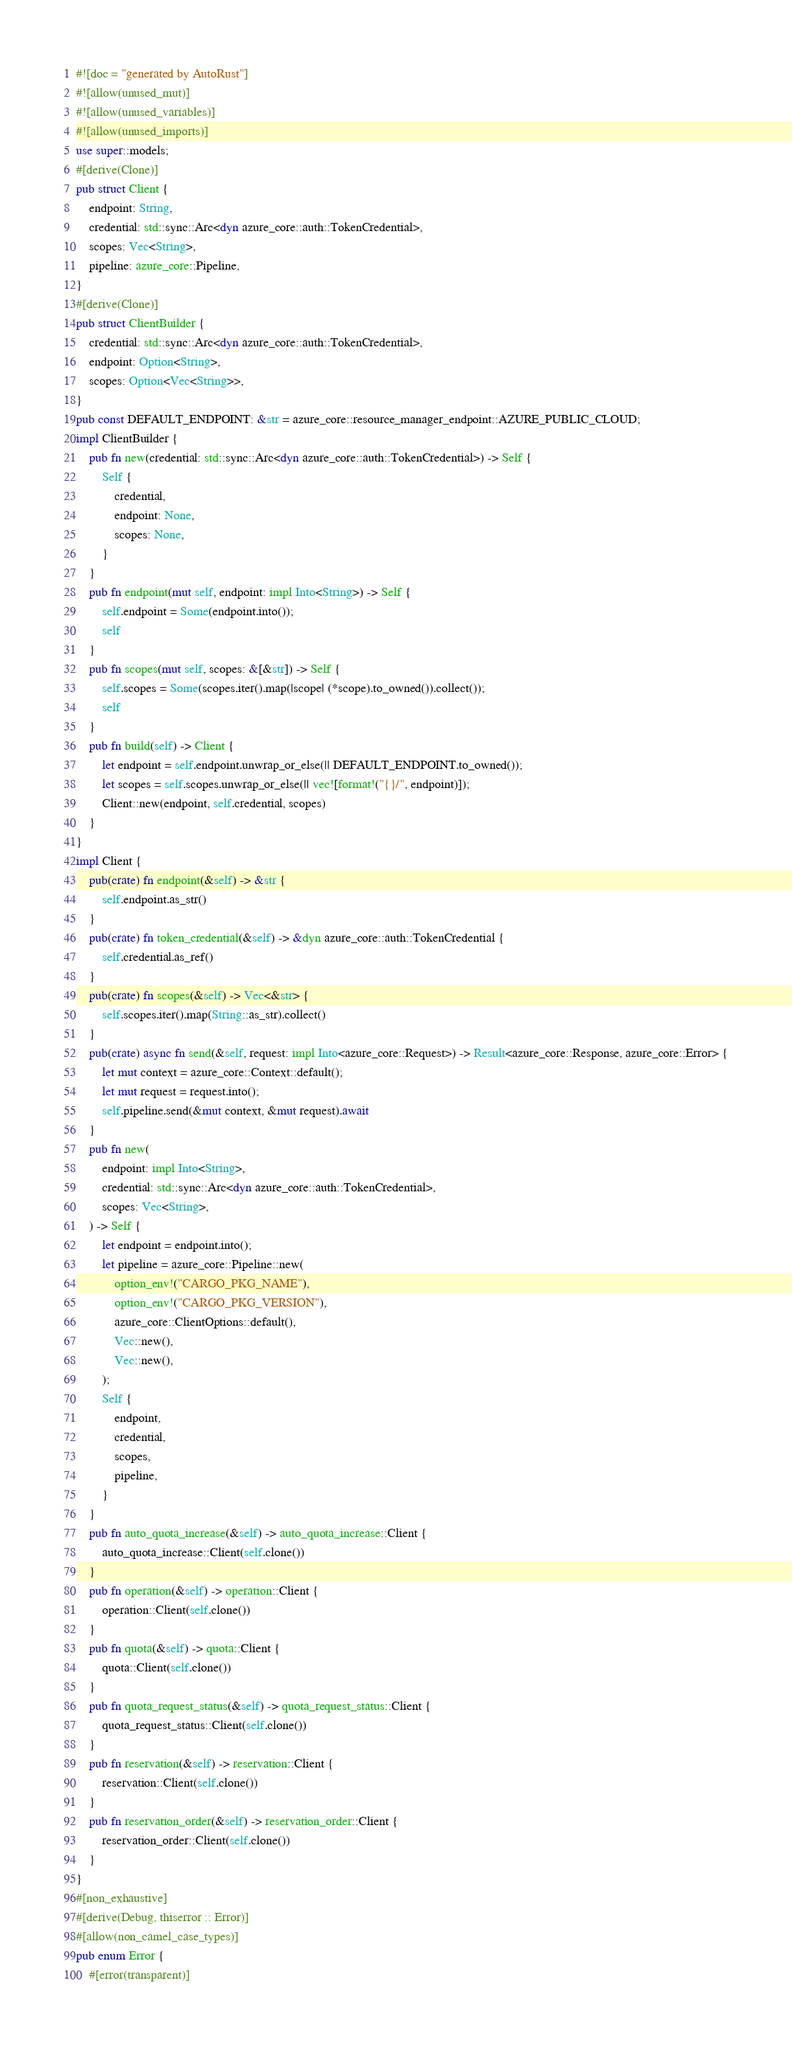Convert code to text. <code><loc_0><loc_0><loc_500><loc_500><_Rust_>#![doc = "generated by AutoRust"]
#![allow(unused_mut)]
#![allow(unused_variables)]
#![allow(unused_imports)]
use super::models;
#[derive(Clone)]
pub struct Client {
    endpoint: String,
    credential: std::sync::Arc<dyn azure_core::auth::TokenCredential>,
    scopes: Vec<String>,
    pipeline: azure_core::Pipeline,
}
#[derive(Clone)]
pub struct ClientBuilder {
    credential: std::sync::Arc<dyn azure_core::auth::TokenCredential>,
    endpoint: Option<String>,
    scopes: Option<Vec<String>>,
}
pub const DEFAULT_ENDPOINT: &str = azure_core::resource_manager_endpoint::AZURE_PUBLIC_CLOUD;
impl ClientBuilder {
    pub fn new(credential: std::sync::Arc<dyn azure_core::auth::TokenCredential>) -> Self {
        Self {
            credential,
            endpoint: None,
            scopes: None,
        }
    }
    pub fn endpoint(mut self, endpoint: impl Into<String>) -> Self {
        self.endpoint = Some(endpoint.into());
        self
    }
    pub fn scopes(mut self, scopes: &[&str]) -> Self {
        self.scopes = Some(scopes.iter().map(|scope| (*scope).to_owned()).collect());
        self
    }
    pub fn build(self) -> Client {
        let endpoint = self.endpoint.unwrap_or_else(|| DEFAULT_ENDPOINT.to_owned());
        let scopes = self.scopes.unwrap_or_else(|| vec![format!("{}/", endpoint)]);
        Client::new(endpoint, self.credential, scopes)
    }
}
impl Client {
    pub(crate) fn endpoint(&self) -> &str {
        self.endpoint.as_str()
    }
    pub(crate) fn token_credential(&self) -> &dyn azure_core::auth::TokenCredential {
        self.credential.as_ref()
    }
    pub(crate) fn scopes(&self) -> Vec<&str> {
        self.scopes.iter().map(String::as_str).collect()
    }
    pub(crate) async fn send(&self, request: impl Into<azure_core::Request>) -> Result<azure_core::Response, azure_core::Error> {
        let mut context = azure_core::Context::default();
        let mut request = request.into();
        self.pipeline.send(&mut context, &mut request).await
    }
    pub fn new(
        endpoint: impl Into<String>,
        credential: std::sync::Arc<dyn azure_core::auth::TokenCredential>,
        scopes: Vec<String>,
    ) -> Self {
        let endpoint = endpoint.into();
        let pipeline = azure_core::Pipeline::new(
            option_env!("CARGO_PKG_NAME"),
            option_env!("CARGO_PKG_VERSION"),
            azure_core::ClientOptions::default(),
            Vec::new(),
            Vec::new(),
        );
        Self {
            endpoint,
            credential,
            scopes,
            pipeline,
        }
    }
    pub fn auto_quota_increase(&self) -> auto_quota_increase::Client {
        auto_quota_increase::Client(self.clone())
    }
    pub fn operation(&self) -> operation::Client {
        operation::Client(self.clone())
    }
    pub fn quota(&self) -> quota::Client {
        quota::Client(self.clone())
    }
    pub fn quota_request_status(&self) -> quota_request_status::Client {
        quota_request_status::Client(self.clone())
    }
    pub fn reservation(&self) -> reservation::Client {
        reservation::Client(self.clone())
    }
    pub fn reservation_order(&self) -> reservation_order::Client {
        reservation_order::Client(self.clone())
    }
}
#[non_exhaustive]
#[derive(Debug, thiserror :: Error)]
#[allow(non_camel_case_types)]
pub enum Error {
    #[error(transparent)]</code> 